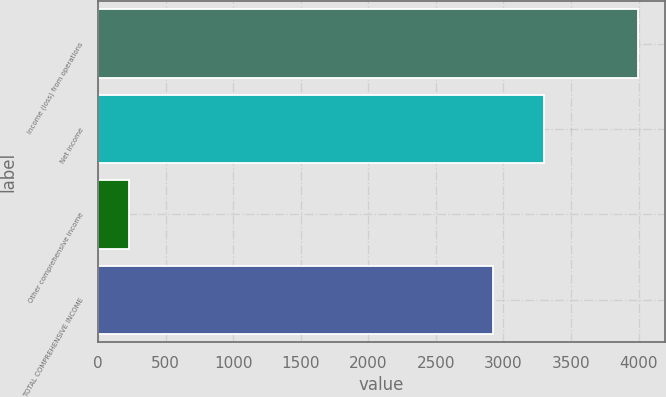<chart> <loc_0><loc_0><loc_500><loc_500><bar_chart><fcel>Income (loss) from operations<fcel>Net income<fcel>Other comprehensive income<fcel>TOTAL COMPREHENSIVE INCOME<nl><fcel>3997<fcel>3297.5<fcel>232<fcel>2921<nl></chart> 